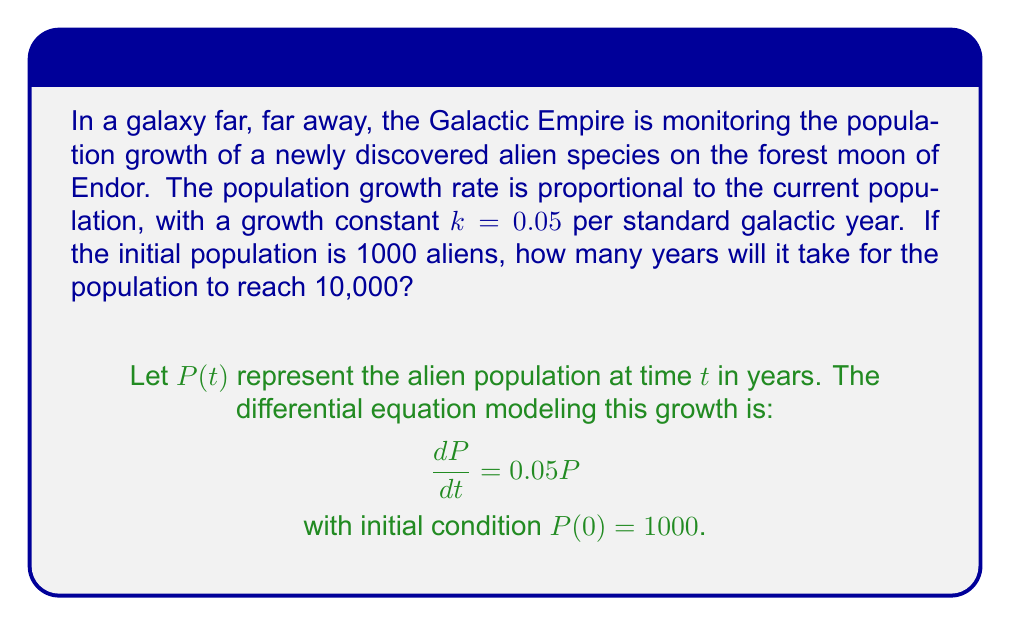Provide a solution to this math problem. Let's solve this step-by-step:

1) The given differential equation is separable. We can rewrite it as:

   $$\frac{dP}{P} = 0.05dt$$

2) Integrating both sides:

   $$\int \frac{dP}{P} = \int 0.05dt$$

   $$\ln|P| = 0.05t + C$$

3) Using the initial condition $P(0) = 1000$, we can find $C$:

   $$\ln(1000) = 0.05(0) + C$$
   $$C = \ln(1000)$$

4) Substituting back:

   $$\ln|P| = 0.05t + \ln(1000)$$

5) Simplifying:

   $$\ln|P| - \ln(1000) = 0.05t$$
   $$\ln\left(\frac{P}{1000}\right) = 0.05t$$

6) Exponentiating both sides:

   $$\frac{P}{1000} = e^{0.05t}$$
   $$P = 1000e^{0.05t}$$

7) We want to find $t$ when $P = 10000$. Substituting:

   $$10000 = 1000e^{0.05t}$$
   $$10 = e^{0.05t}$$

8) Taking natural log of both sides:

   $$\ln(10) = 0.05t$$

9) Solving for $t$:

   $$t = \frac{\ln(10)}{0.05} \approx 46.05$$

Therefore, it will take approximately 46.05 standard galactic years for the population to reach 10,000.
Answer: 46.05 years 